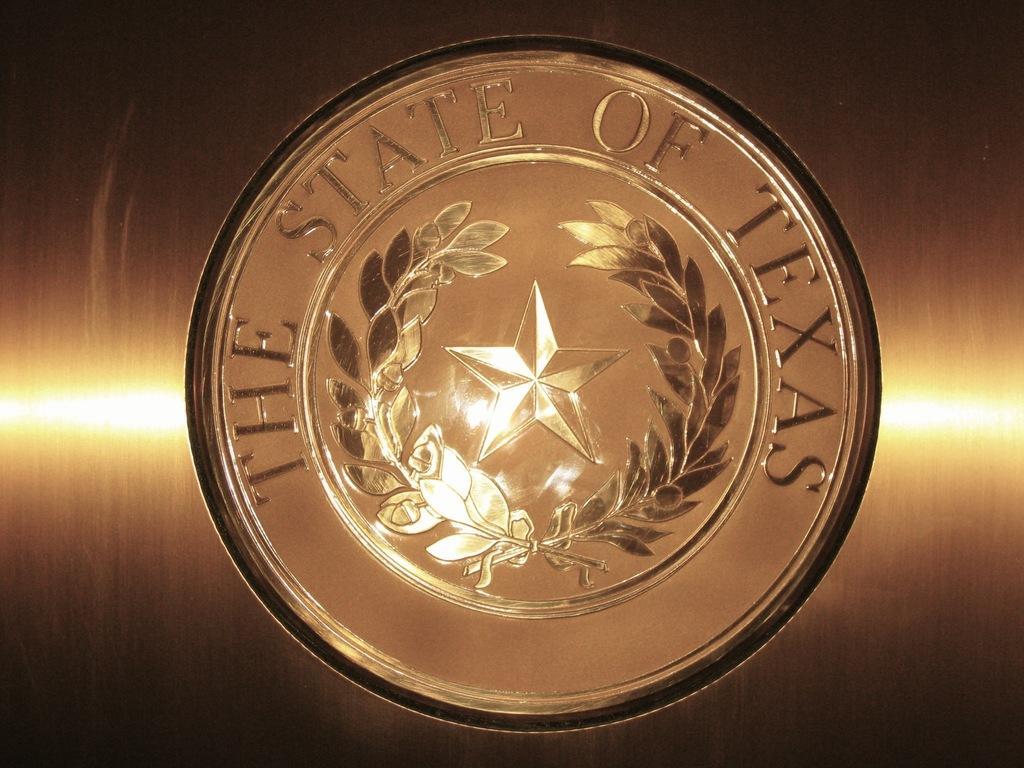Describe this image in one or two sentences. In this image, we can see a logo with some text. 